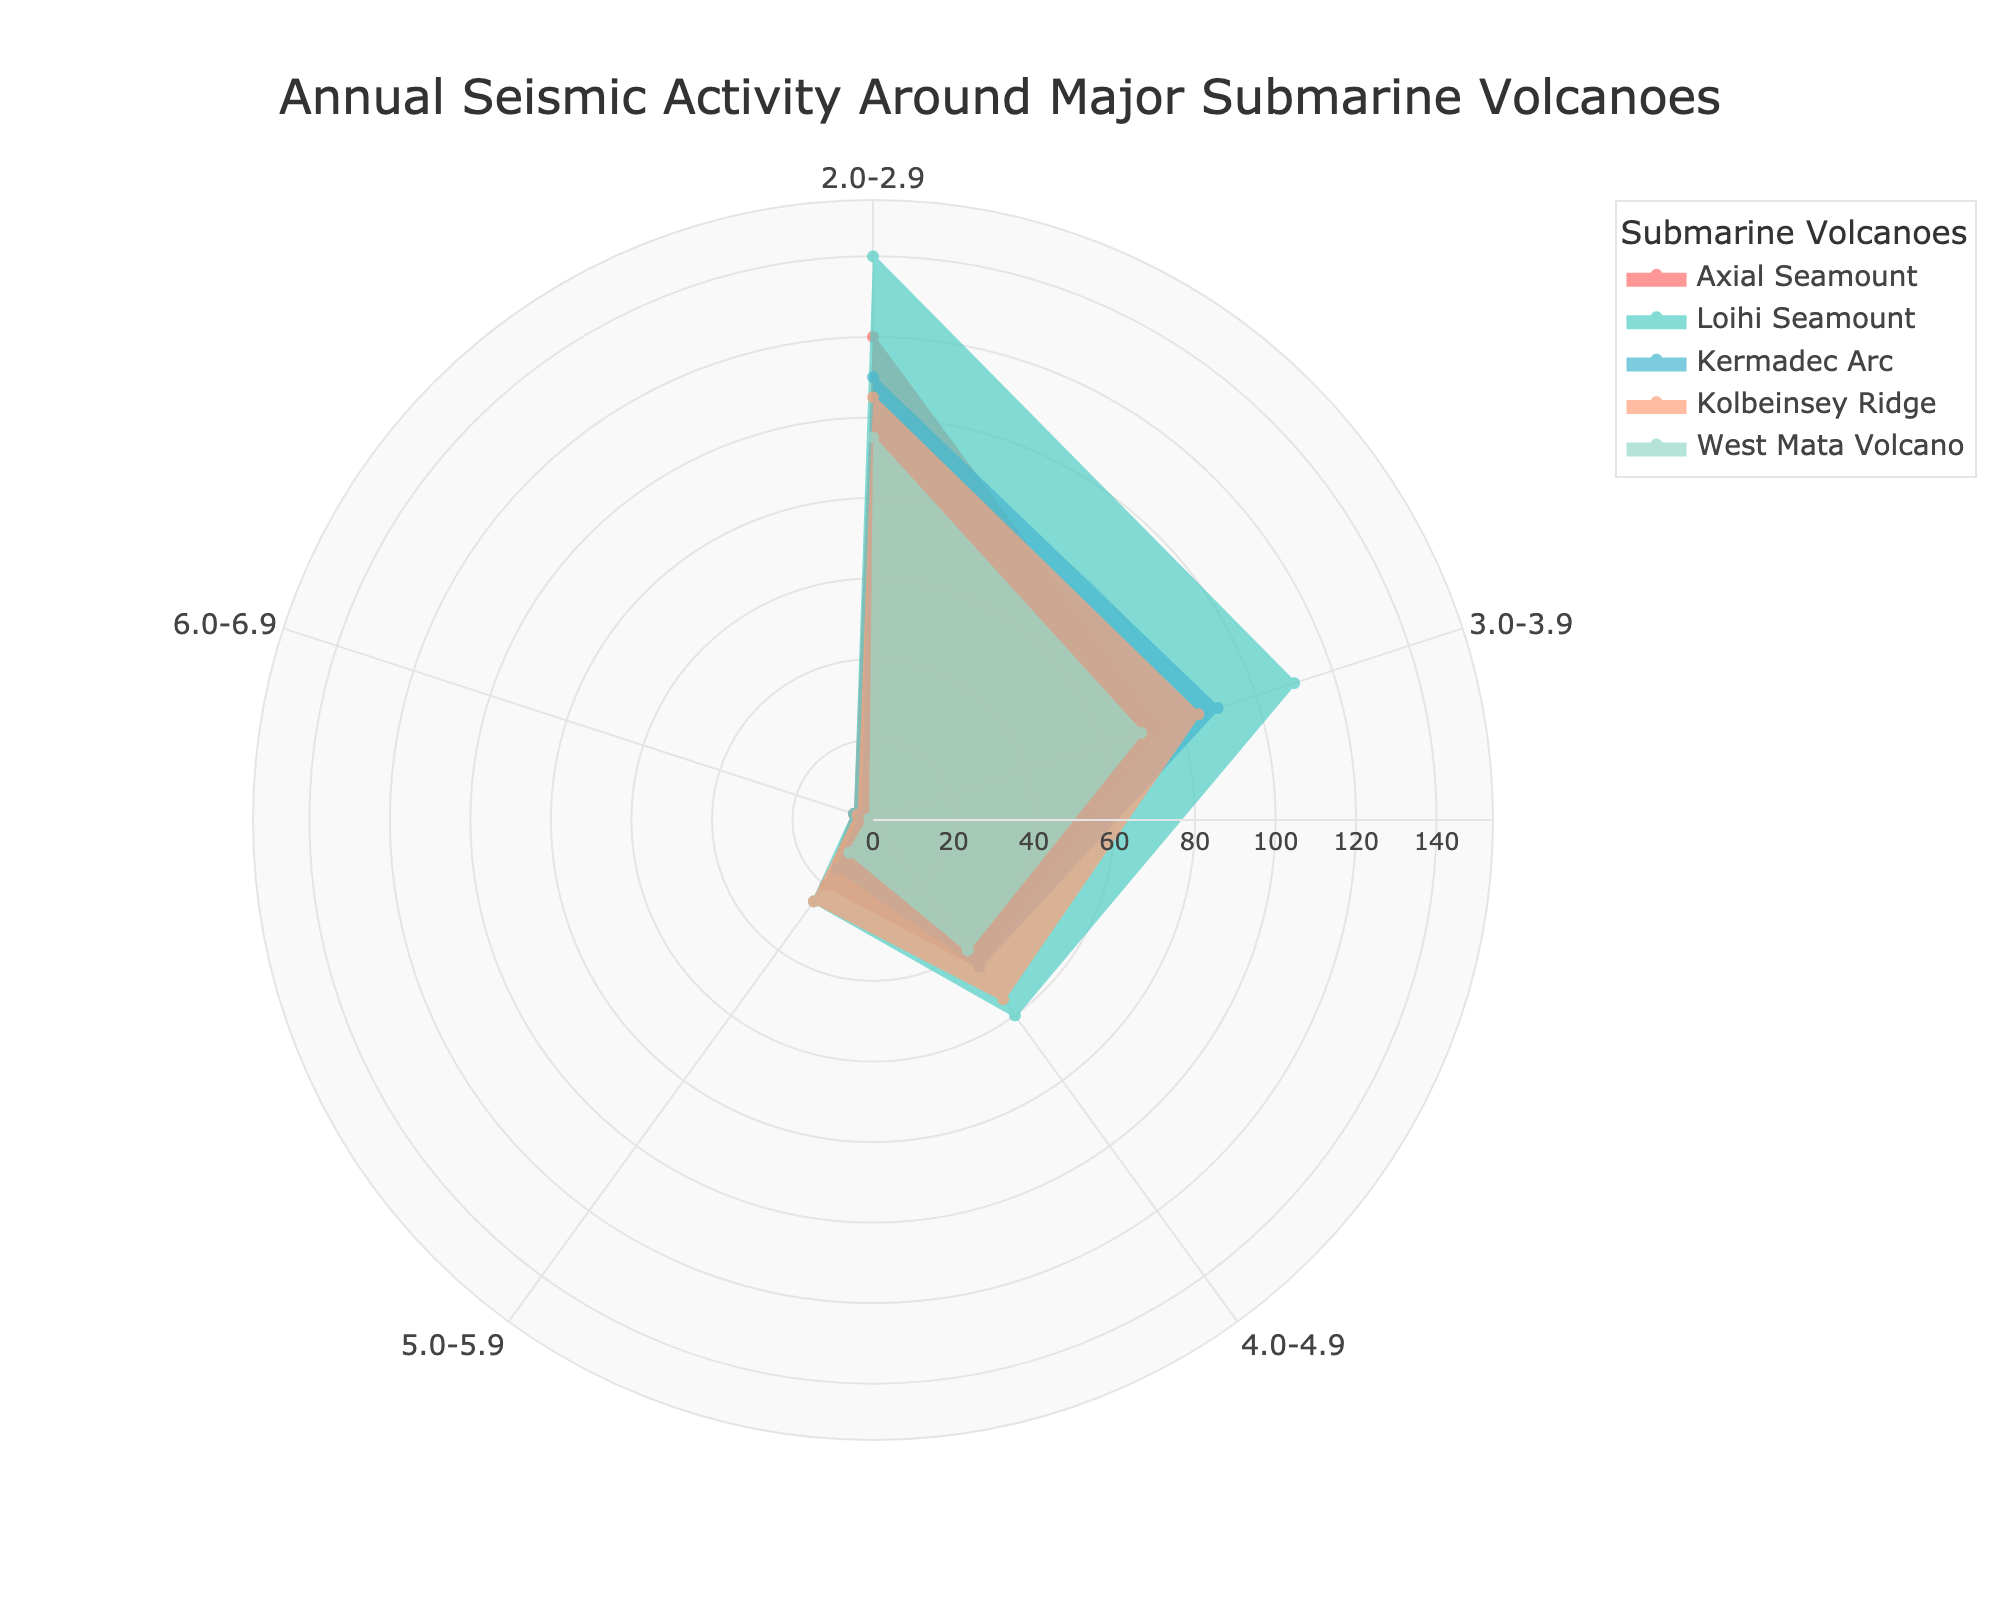What is the title of the figure? The title is usually prominently displayed at the top of the figure. In this case, the title reads "Annual Seismic Activity Around Major Submarine Volcanoes."
Answer: Annual Seismic Activity Around Major Submarine Volcanoes Which submarine volcano has the highest seismic activity for magnitudes between 3.0-3.9? By examining the "3.0-3.9" magnitude section and looking at the lengths of the sections corresponding to different submarine volcanoes, the longest one belongs to the Loihi Seamount.
Answer: Loihi Seamount How many seismic activities of magnitude 4.0-4.9 were recorded for the Kermadec Arc? Looking at the section of the chart corresponding to the "4.0-4.9" magnitude and the Kermadec Arc, it shows there were 45 seismic activities.
Answer: 45 Which submarine volcano has the least seismic activity for magnitudes between 5.0-5.9? Among the sections representing the "5.0-5.9" magnitude across different volcanoes, the shortest bar belongs to the West Mata Volcano.
Answer: West Mata Volcano What's the total number of seismic activities recorded for the Axial Seamount for all magnitudes combined? To find the total, sum the values for the Axial Seamount across all magnitudes: 120 + 75 + 45 + 20 + 5 = 265.
Answer: 265 Which submarine volcano shows no significant difference between seismic activities of magnitude 5.0-5.9 and 6.0-6.9? By comparing the heights of the sections for "5.0-5.9" and "6.0-6.9" magnitudes, Kolbeinsey Ridge has similar values (25 for 5.0-5.9 and 4 for 6.0-6.9).
Answer: Kolbeinsey Ridge What's the difference in the number of seismic activities between magnitudes 4.0-4.9 and 3.0-3.9 for the Loihi Seamount? For the Loihi Seamount, the number of seismic activities for 3.0-3.9 is 110 and for 4.0-4.9 is 60. The difference is 110 - 60 = 50.
Answer: 50 Which submarine volcano has shown a decrease in seismic activity as the magnitude increases? Observing the bars for each volcano, it can be seen that all volcanoes, including Axial Seamount, Loihi Seamount, Kermadec Arc, Kolbeinsey Ridge, and West Mata Volcano, show a trend of decreasing seismic activity with increasing magnitude.
Answer: All listed volcanoes What color represents the Kolbeinsey Ridge in the plot? By looking at the legend, the Kolbeinsey Ridge is represented by a salmon-like color.
Answer: Salmon color 